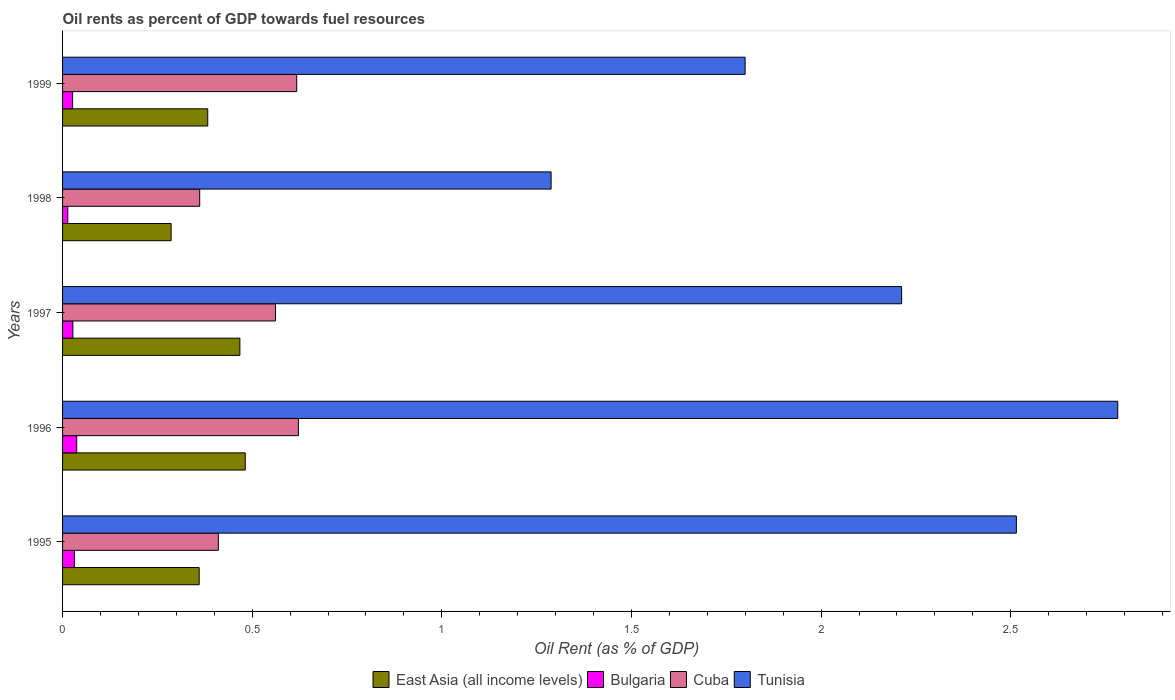How many different coloured bars are there?
Offer a very short reply. 4. Are the number of bars per tick equal to the number of legend labels?
Offer a terse response. Yes. How many bars are there on the 2nd tick from the top?
Provide a succinct answer. 4. What is the label of the 4th group of bars from the top?
Provide a short and direct response. 1996. What is the oil rent in Cuba in 1999?
Provide a short and direct response. 0.62. Across all years, what is the maximum oil rent in Bulgaria?
Keep it short and to the point. 0.04. Across all years, what is the minimum oil rent in Tunisia?
Your answer should be very brief. 1.29. In which year was the oil rent in Tunisia maximum?
Provide a short and direct response. 1996. What is the total oil rent in Tunisia in the graph?
Offer a very short reply. 10.6. What is the difference between the oil rent in Cuba in 1996 and that in 1997?
Provide a succinct answer. 0.06. What is the difference between the oil rent in Cuba in 1996 and the oil rent in Bulgaria in 1995?
Keep it short and to the point. 0.59. What is the average oil rent in East Asia (all income levels) per year?
Make the answer very short. 0.4. In the year 1996, what is the difference between the oil rent in Cuba and oil rent in East Asia (all income levels)?
Provide a succinct answer. 0.14. What is the ratio of the oil rent in Tunisia in 1997 to that in 1999?
Ensure brevity in your answer.  1.23. What is the difference between the highest and the second highest oil rent in Tunisia?
Keep it short and to the point. 0.27. What is the difference between the highest and the lowest oil rent in Bulgaria?
Your answer should be very brief. 0.02. Is the sum of the oil rent in East Asia (all income levels) in 1997 and 1999 greater than the maximum oil rent in Bulgaria across all years?
Your response must be concise. Yes. Is it the case that in every year, the sum of the oil rent in Tunisia and oil rent in Cuba is greater than the sum of oil rent in Bulgaria and oil rent in East Asia (all income levels)?
Make the answer very short. Yes. What does the 1st bar from the top in 1999 represents?
Make the answer very short. Tunisia. What does the 4th bar from the bottom in 1999 represents?
Provide a short and direct response. Tunisia. Are all the bars in the graph horizontal?
Your response must be concise. Yes. Are the values on the major ticks of X-axis written in scientific E-notation?
Your answer should be compact. No. Does the graph contain grids?
Offer a terse response. No. Where does the legend appear in the graph?
Your answer should be compact. Bottom center. What is the title of the graph?
Give a very brief answer. Oil rents as percent of GDP towards fuel resources. What is the label or title of the X-axis?
Your answer should be compact. Oil Rent (as % of GDP). What is the Oil Rent (as % of GDP) of East Asia (all income levels) in 1995?
Your answer should be very brief. 0.36. What is the Oil Rent (as % of GDP) in Bulgaria in 1995?
Provide a short and direct response. 0.03. What is the Oil Rent (as % of GDP) of Cuba in 1995?
Provide a succinct answer. 0.41. What is the Oil Rent (as % of GDP) in Tunisia in 1995?
Make the answer very short. 2.51. What is the Oil Rent (as % of GDP) in East Asia (all income levels) in 1996?
Offer a very short reply. 0.48. What is the Oil Rent (as % of GDP) of Bulgaria in 1996?
Give a very brief answer. 0.04. What is the Oil Rent (as % of GDP) in Cuba in 1996?
Make the answer very short. 0.62. What is the Oil Rent (as % of GDP) of Tunisia in 1996?
Provide a succinct answer. 2.78. What is the Oil Rent (as % of GDP) of East Asia (all income levels) in 1997?
Offer a terse response. 0.47. What is the Oil Rent (as % of GDP) of Bulgaria in 1997?
Your answer should be compact. 0.03. What is the Oil Rent (as % of GDP) in Cuba in 1997?
Make the answer very short. 0.56. What is the Oil Rent (as % of GDP) of Tunisia in 1997?
Your response must be concise. 2.21. What is the Oil Rent (as % of GDP) in East Asia (all income levels) in 1998?
Offer a very short reply. 0.29. What is the Oil Rent (as % of GDP) in Bulgaria in 1998?
Make the answer very short. 0.01. What is the Oil Rent (as % of GDP) of Cuba in 1998?
Give a very brief answer. 0.36. What is the Oil Rent (as % of GDP) in Tunisia in 1998?
Provide a succinct answer. 1.29. What is the Oil Rent (as % of GDP) of East Asia (all income levels) in 1999?
Your answer should be very brief. 0.38. What is the Oil Rent (as % of GDP) of Bulgaria in 1999?
Provide a succinct answer. 0.03. What is the Oil Rent (as % of GDP) of Cuba in 1999?
Give a very brief answer. 0.62. What is the Oil Rent (as % of GDP) of Tunisia in 1999?
Ensure brevity in your answer.  1.8. Across all years, what is the maximum Oil Rent (as % of GDP) in East Asia (all income levels)?
Your answer should be compact. 0.48. Across all years, what is the maximum Oil Rent (as % of GDP) in Bulgaria?
Keep it short and to the point. 0.04. Across all years, what is the maximum Oil Rent (as % of GDP) of Cuba?
Offer a very short reply. 0.62. Across all years, what is the maximum Oil Rent (as % of GDP) in Tunisia?
Make the answer very short. 2.78. Across all years, what is the minimum Oil Rent (as % of GDP) in East Asia (all income levels)?
Your answer should be very brief. 0.29. Across all years, what is the minimum Oil Rent (as % of GDP) in Bulgaria?
Offer a very short reply. 0.01. Across all years, what is the minimum Oil Rent (as % of GDP) in Cuba?
Keep it short and to the point. 0.36. Across all years, what is the minimum Oil Rent (as % of GDP) of Tunisia?
Provide a short and direct response. 1.29. What is the total Oil Rent (as % of GDP) of East Asia (all income levels) in the graph?
Your response must be concise. 1.98. What is the total Oil Rent (as % of GDP) in Bulgaria in the graph?
Your answer should be very brief. 0.14. What is the total Oil Rent (as % of GDP) in Cuba in the graph?
Keep it short and to the point. 2.57. What is the total Oil Rent (as % of GDP) in Tunisia in the graph?
Offer a very short reply. 10.6. What is the difference between the Oil Rent (as % of GDP) in East Asia (all income levels) in 1995 and that in 1996?
Your response must be concise. -0.12. What is the difference between the Oil Rent (as % of GDP) of Bulgaria in 1995 and that in 1996?
Give a very brief answer. -0.01. What is the difference between the Oil Rent (as % of GDP) of Cuba in 1995 and that in 1996?
Give a very brief answer. -0.21. What is the difference between the Oil Rent (as % of GDP) in Tunisia in 1995 and that in 1996?
Give a very brief answer. -0.27. What is the difference between the Oil Rent (as % of GDP) of East Asia (all income levels) in 1995 and that in 1997?
Your answer should be very brief. -0.11. What is the difference between the Oil Rent (as % of GDP) in Bulgaria in 1995 and that in 1997?
Give a very brief answer. 0. What is the difference between the Oil Rent (as % of GDP) in Cuba in 1995 and that in 1997?
Offer a very short reply. -0.15. What is the difference between the Oil Rent (as % of GDP) of Tunisia in 1995 and that in 1997?
Provide a succinct answer. 0.3. What is the difference between the Oil Rent (as % of GDP) of East Asia (all income levels) in 1995 and that in 1998?
Give a very brief answer. 0.07. What is the difference between the Oil Rent (as % of GDP) in Bulgaria in 1995 and that in 1998?
Make the answer very short. 0.02. What is the difference between the Oil Rent (as % of GDP) of Cuba in 1995 and that in 1998?
Provide a succinct answer. 0.05. What is the difference between the Oil Rent (as % of GDP) of Tunisia in 1995 and that in 1998?
Your answer should be compact. 1.23. What is the difference between the Oil Rent (as % of GDP) of East Asia (all income levels) in 1995 and that in 1999?
Offer a very short reply. -0.02. What is the difference between the Oil Rent (as % of GDP) in Bulgaria in 1995 and that in 1999?
Offer a terse response. 0. What is the difference between the Oil Rent (as % of GDP) in Cuba in 1995 and that in 1999?
Your response must be concise. -0.21. What is the difference between the Oil Rent (as % of GDP) in Tunisia in 1995 and that in 1999?
Ensure brevity in your answer.  0.72. What is the difference between the Oil Rent (as % of GDP) of East Asia (all income levels) in 1996 and that in 1997?
Provide a succinct answer. 0.01. What is the difference between the Oil Rent (as % of GDP) in Bulgaria in 1996 and that in 1997?
Provide a short and direct response. 0.01. What is the difference between the Oil Rent (as % of GDP) of Cuba in 1996 and that in 1997?
Keep it short and to the point. 0.06. What is the difference between the Oil Rent (as % of GDP) in Tunisia in 1996 and that in 1997?
Your answer should be very brief. 0.57. What is the difference between the Oil Rent (as % of GDP) of East Asia (all income levels) in 1996 and that in 1998?
Provide a short and direct response. 0.2. What is the difference between the Oil Rent (as % of GDP) of Bulgaria in 1996 and that in 1998?
Your response must be concise. 0.02. What is the difference between the Oil Rent (as % of GDP) of Cuba in 1996 and that in 1998?
Make the answer very short. 0.26. What is the difference between the Oil Rent (as % of GDP) of Tunisia in 1996 and that in 1998?
Offer a terse response. 1.49. What is the difference between the Oil Rent (as % of GDP) of East Asia (all income levels) in 1996 and that in 1999?
Your answer should be very brief. 0.1. What is the difference between the Oil Rent (as % of GDP) of Bulgaria in 1996 and that in 1999?
Keep it short and to the point. 0.01. What is the difference between the Oil Rent (as % of GDP) of Cuba in 1996 and that in 1999?
Your answer should be compact. 0. What is the difference between the Oil Rent (as % of GDP) in Tunisia in 1996 and that in 1999?
Ensure brevity in your answer.  0.98. What is the difference between the Oil Rent (as % of GDP) of East Asia (all income levels) in 1997 and that in 1998?
Your response must be concise. 0.18. What is the difference between the Oil Rent (as % of GDP) in Bulgaria in 1997 and that in 1998?
Offer a terse response. 0.01. What is the difference between the Oil Rent (as % of GDP) of Cuba in 1997 and that in 1998?
Give a very brief answer. 0.2. What is the difference between the Oil Rent (as % of GDP) of Tunisia in 1997 and that in 1998?
Your answer should be very brief. 0.92. What is the difference between the Oil Rent (as % of GDP) in East Asia (all income levels) in 1997 and that in 1999?
Offer a terse response. 0.08. What is the difference between the Oil Rent (as % of GDP) of Bulgaria in 1997 and that in 1999?
Your response must be concise. 0. What is the difference between the Oil Rent (as % of GDP) in Cuba in 1997 and that in 1999?
Your response must be concise. -0.06. What is the difference between the Oil Rent (as % of GDP) in Tunisia in 1997 and that in 1999?
Provide a short and direct response. 0.41. What is the difference between the Oil Rent (as % of GDP) in East Asia (all income levels) in 1998 and that in 1999?
Your response must be concise. -0.1. What is the difference between the Oil Rent (as % of GDP) in Bulgaria in 1998 and that in 1999?
Offer a terse response. -0.01. What is the difference between the Oil Rent (as % of GDP) in Cuba in 1998 and that in 1999?
Your response must be concise. -0.26. What is the difference between the Oil Rent (as % of GDP) of Tunisia in 1998 and that in 1999?
Your answer should be very brief. -0.51. What is the difference between the Oil Rent (as % of GDP) in East Asia (all income levels) in 1995 and the Oil Rent (as % of GDP) in Bulgaria in 1996?
Give a very brief answer. 0.32. What is the difference between the Oil Rent (as % of GDP) of East Asia (all income levels) in 1995 and the Oil Rent (as % of GDP) of Cuba in 1996?
Provide a succinct answer. -0.26. What is the difference between the Oil Rent (as % of GDP) in East Asia (all income levels) in 1995 and the Oil Rent (as % of GDP) in Tunisia in 1996?
Offer a very short reply. -2.42. What is the difference between the Oil Rent (as % of GDP) in Bulgaria in 1995 and the Oil Rent (as % of GDP) in Cuba in 1996?
Your answer should be compact. -0.59. What is the difference between the Oil Rent (as % of GDP) of Bulgaria in 1995 and the Oil Rent (as % of GDP) of Tunisia in 1996?
Make the answer very short. -2.75. What is the difference between the Oil Rent (as % of GDP) of Cuba in 1995 and the Oil Rent (as % of GDP) of Tunisia in 1996?
Offer a very short reply. -2.37. What is the difference between the Oil Rent (as % of GDP) in East Asia (all income levels) in 1995 and the Oil Rent (as % of GDP) in Bulgaria in 1997?
Offer a very short reply. 0.33. What is the difference between the Oil Rent (as % of GDP) of East Asia (all income levels) in 1995 and the Oil Rent (as % of GDP) of Cuba in 1997?
Provide a short and direct response. -0.2. What is the difference between the Oil Rent (as % of GDP) in East Asia (all income levels) in 1995 and the Oil Rent (as % of GDP) in Tunisia in 1997?
Your answer should be compact. -1.85. What is the difference between the Oil Rent (as % of GDP) in Bulgaria in 1995 and the Oil Rent (as % of GDP) in Cuba in 1997?
Ensure brevity in your answer.  -0.53. What is the difference between the Oil Rent (as % of GDP) in Bulgaria in 1995 and the Oil Rent (as % of GDP) in Tunisia in 1997?
Your response must be concise. -2.18. What is the difference between the Oil Rent (as % of GDP) in Cuba in 1995 and the Oil Rent (as % of GDP) in Tunisia in 1997?
Give a very brief answer. -1.8. What is the difference between the Oil Rent (as % of GDP) of East Asia (all income levels) in 1995 and the Oil Rent (as % of GDP) of Bulgaria in 1998?
Give a very brief answer. 0.35. What is the difference between the Oil Rent (as % of GDP) in East Asia (all income levels) in 1995 and the Oil Rent (as % of GDP) in Cuba in 1998?
Keep it short and to the point. -0. What is the difference between the Oil Rent (as % of GDP) of East Asia (all income levels) in 1995 and the Oil Rent (as % of GDP) of Tunisia in 1998?
Your answer should be very brief. -0.93. What is the difference between the Oil Rent (as % of GDP) of Bulgaria in 1995 and the Oil Rent (as % of GDP) of Cuba in 1998?
Your response must be concise. -0.33. What is the difference between the Oil Rent (as % of GDP) in Bulgaria in 1995 and the Oil Rent (as % of GDP) in Tunisia in 1998?
Make the answer very short. -1.26. What is the difference between the Oil Rent (as % of GDP) in Cuba in 1995 and the Oil Rent (as % of GDP) in Tunisia in 1998?
Provide a short and direct response. -0.88. What is the difference between the Oil Rent (as % of GDP) in East Asia (all income levels) in 1995 and the Oil Rent (as % of GDP) in Bulgaria in 1999?
Ensure brevity in your answer.  0.33. What is the difference between the Oil Rent (as % of GDP) in East Asia (all income levels) in 1995 and the Oil Rent (as % of GDP) in Cuba in 1999?
Ensure brevity in your answer.  -0.26. What is the difference between the Oil Rent (as % of GDP) of East Asia (all income levels) in 1995 and the Oil Rent (as % of GDP) of Tunisia in 1999?
Provide a short and direct response. -1.44. What is the difference between the Oil Rent (as % of GDP) of Bulgaria in 1995 and the Oil Rent (as % of GDP) of Cuba in 1999?
Your response must be concise. -0.59. What is the difference between the Oil Rent (as % of GDP) in Bulgaria in 1995 and the Oil Rent (as % of GDP) in Tunisia in 1999?
Offer a terse response. -1.77. What is the difference between the Oil Rent (as % of GDP) in Cuba in 1995 and the Oil Rent (as % of GDP) in Tunisia in 1999?
Provide a succinct answer. -1.39. What is the difference between the Oil Rent (as % of GDP) of East Asia (all income levels) in 1996 and the Oil Rent (as % of GDP) of Bulgaria in 1997?
Offer a terse response. 0.45. What is the difference between the Oil Rent (as % of GDP) of East Asia (all income levels) in 1996 and the Oil Rent (as % of GDP) of Cuba in 1997?
Give a very brief answer. -0.08. What is the difference between the Oil Rent (as % of GDP) in East Asia (all income levels) in 1996 and the Oil Rent (as % of GDP) in Tunisia in 1997?
Give a very brief answer. -1.73. What is the difference between the Oil Rent (as % of GDP) in Bulgaria in 1996 and the Oil Rent (as % of GDP) in Cuba in 1997?
Offer a terse response. -0.52. What is the difference between the Oil Rent (as % of GDP) of Bulgaria in 1996 and the Oil Rent (as % of GDP) of Tunisia in 1997?
Ensure brevity in your answer.  -2.18. What is the difference between the Oil Rent (as % of GDP) of Cuba in 1996 and the Oil Rent (as % of GDP) of Tunisia in 1997?
Your response must be concise. -1.59. What is the difference between the Oil Rent (as % of GDP) in East Asia (all income levels) in 1996 and the Oil Rent (as % of GDP) in Bulgaria in 1998?
Provide a succinct answer. 0.47. What is the difference between the Oil Rent (as % of GDP) in East Asia (all income levels) in 1996 and the Oil Rent (as % of GDP) in Cuba in 1998?
Offer a terse response. 0.12. What is the difference between the Oil Rent (as % of GDP) in East Asia (all income levels) in 1996 and the Oil Rent (as % of GDP) in Tunisia in 1998?
Make the answer very short. -0.81. What is the difference between the Oil Rent (as % of GDP) in Bulgaria in 1996 and the Oil Rent (as % of GDP) in Cuba in 1998?
Your response must be concise. -0.32. What is the difference between the Oil Rent (as % of GDP) of Bulgaria in 1996 and the Oil Rent (as % of GDP) of Tunisia in 1998?
Give a very brief answer. -1.25. What is the difference between the Oil Rent (as % of GDP) in Cuba in 1996 and the Oil Rent (as % of GDP) in Tunisia in 1998?
Provide a succinct answer. -0.67. What is the difference between the Oil Rent (as % of GDP) in East Asia (all income levels) in 1996 and the Oil Rent (as % of GDP) in Bulgaria in 1999?
Give a very brief answer. 0.46. What is the difference between the Oil Rent (as % of GDP) in East Asia (all income levels) in 1996 and the Oil Rent (as % of GDP) in Cuba in 1999?
Keep it short and to the point. -0.14. What is the difference between the Oil Rent (as % of GDP) in East Asia (all income levels) in 1996 and the Oil Rent (as % of GDP) in Tunisia in 1999?
Your answer should be compact. -1.32. What is the difference between the Oil Rent (as % of GDP) in Bulgaria in 1996 and the Oil Rent (as % of GDP) in Cuba in 1999?
Offer a very short reply. -0.58. What is the difference between the Oil Rent (as % of GDP) of Bulgaria in 1996 and the Oil Rent (as % of GDP) of Tunisia in 1999?
Offer a terse response. -1.76. What is the difference between the Oil Rent (as % of GDP) in Cuba in 1996 and the Oil Rent (as % of GDP) in Tunisia in 1999?
Your answer should be compact. -1.18. What is the difference between the Oil Rent (as % of GDP) in East Asia (all income levels) in 1997 and the Oil Rent (as % of GDP) in Bulgaria in 1998?
Ensure brevity in your answer.  0.45. What is the difference between the Oil Rent (as % of GDP) of East Asia (all income levels) in 1997 and the Oil Rent (as % of GDP) of Cuba in 1998?
Make the answer very short. 0.11. What is the difference between the Oil Rent (as % of GDP) in East Asia (all income levels) in 1997 and the Oil Rent (as % of GDP) in Tunisia in 1998?
Give a very brief answer. -0.82. What is the difference between the Oil Rent (as % of GDP) of Bulgaria in 1997 and the Oil Rent (as % of GDP) of Cuba in 1998?
Your answer should be compact. -0.33. What is the difference between the Oil Rent (as % of GDP) in Bulgaria in 1997 and the Oil Rent (as % of GDP) in Tunisia in 1998?
Give a very brief answer. -1.26. What is the difference between the Oil Rent (as % of GDP) in Cuba in 1997 and the Oil Rent (as % of GDP) in Tunisia in 1998?
Keep it short and to the point. -0.73. What is the difference between the Oil Rent (as % of GDP) of East Asia (all income levels) in 1997 and the Oil Rent (as % of GDP) of Bulgaria in 1999?
Provide a succinct answer. 0.44. What is the difference between the Oil Rent (as % of GDP) in East Asia (all income levels) in 1997 and the Oil Rent (as % of GDP) in Cuba in 1999?
Give a very brief answer. -0.15. What is the difference between the Oil Rent (as % of GDP) in East Asia (all income levels) in 1997 and the Oil Rent (as % of GDP) in Tunisia in 1999?
Offer a very short reply. -1.33. What is the difference between the Oil Rent (as % of GDP) in Bulgaria in 1997 and the Oil Rent (as % of GDP) in Cuba in 1999?
Ensure brevity in your answer.  -0.59. What is the difference between the Oil Rent (as % of GDP) of Bulgaria in 1997 and the Oil Rent (as % of GDP) of Tunisia in 1999?
Your answer should be very brief. -1.77. What is the difference between the Oil Rent (as % of GDP) of Cuba in 1997 and the Oil Rent (as % of GDP) of Tunisia in 1999?
Ensure brevity in your answer.  -1.24. What is the difference between the Oil Rent (as % of GDP) in East Asia (all income levels) in 1998 and the Oil Rent (as % of GDP) in Bulgaria in 1999?
Your answer should be compact. 0.26. What is the difference between the Oil Rent (as % of GDP) in East Asia (all income levels) in 1998 and the Oil Rent (as % of GDP) in Cuba in 1999?
Your response must be concise. -0.33. What is the difference between the Oil Rent (as % of GDP) in East Asia (all income levels) in 1998 and the Oil Rent (as % of GDP) in Tunisia in 1999?
Keep it short and to the point. -1.51. What is the difference between the Oil Rent (as % of GDP) in Bulgaria in 1998 and the Oil Rent (as % of GDP) in Cuba in 1999?
Ensure brevity in your answer.  -0.6. What is the difference between the Oil Rent (as % of GDP) in Bulgaria in 1998 and the Oil Rent (as % of GDP) in Tunisia in 1999?
Ensure brevity in your answer.  -1.79. What is the difference between the Oil Rent (as % of GDP) of Cuba in 1998 and the Oil Rent (as % of GDP) of Tunisia in 1999?
Make the answer very short. -1.44. What is the average Oil Rent (as % of GDP) of East Asia (all income levels) per year?
Ensure brevity in your answer.  0.4. What is the average Oil Rent (as % of GDP) of Bulgaria per year?
Your answer should be very brief. 0.03. What is the average Oil Rent (as % of GDP) in Cuba per year?
Offer a terse response. 0.51. What is the average Oil Rent (as % of GDP) in Tunisia per year?
Offer a terse response. 2.12. In the year 1995, what is the difference between the Oil Rent (as % of GDP) in East Asia (all income levels) and Oil Rent (as % of GDP) in Bulgaria?
Give a very brief answer. 0.33. In the year 1995, what is the difference between the Oil Rent (as % of GDP) in East Asia (all income levels) and Oil Rent (as % of GDP) in Cuba?
Offer a very short reply. -0.05. In the year 1995, what is the difference between the Oil Rent (as % of GDP) of East Asia (all income levels) and Oil Rent (as % of GDP) of Tunisia?
Keep it short and to the point. -2.15. In the year 1995, what is the difference between the Oil Rent (as % of GDP) of Bulgaria and Oil Rent (as % of GDP) of Cuba?
Ensure brevity in your answer.  -0.38. In the year 1995, what is the difference between the Oil Rent (as % of GDP) of Bulgaria and Oil Rent (as % of GDP) of Tunisia?
Make the answer very short. -2.48. In the year 1995, what is the difference between the Oil Rent (as % of GDP) in Cuba and Oil Rent (as % of GDP) in Tunisia?
Offer a terse response. -2.1. In the year 1996, what is the difference between the Oil Rent (as % of GDP) of East Asia (all income levels) and Oil Rent (as % of GDP) of Bulgaria?
Ensure brevity in your answer.  0.44. In the year 1996, what is the difference between the Oil Rent (as % of GDP) of East Asia (all income levels) and Oil Rent (as % of GDP) of Cuba?
Your answer should be compact. -0.14. In the year 1996, what is the difference between the Oil Rent (as % of GDP) in East Asia (all income levels) and Oil Rent (as % of GDP) in Tunisia?
Offer a very short reply. -2.3. In the year 1996, what is the difference between the Oil Rent (as % of GDP) of Bulgaria and Oil Rent (as % of GDP) of Cuba?
Give a very brief answer. -0.58. In the year 1996, what is the difference between the Oil Rent (as % of GDP) in Bulgaria and Oil Rent (as % of GDP) in Tunisia?
Provide a succinct answer. -2.74. In the year 1996, what is the difference between the Oil Rent (as % of GDP) of Cuba and Oil Rent (as % of GDP) of Tunisia?
Your answer should be compact. -2.16. In the year 1997, what is the difference between the Oil Rent (as % of GDP) in East Asia (all income levels) and Oil Rent (as % of GDP) in Bulgaria?
Your answer should be compact. 0.44. In the year 1997, what is the difference between the Oil Rent (as % of GDP) of East Asia (all income levels) and Oil Rent (as % of GDP) of Cuba?
Your answer should be compact. -0.09. In the year 1997, what is the difference between the Oil Rent (as % of GDP) of East Asia (all income levels) and Oil Rent (as % of GDP) of Tunisia?
Offer a very short reply. -1.74. In the year 1997, what is the difference between the Oil Rent (as % of GDP) of Bulgaria and Oil Rent (as % of GDP) of Cuba?
Offer a terse response. -0.53. In the year 1997, what is the difference between the Oil Rent (as % of GDP) in Bulgaria and Oil Rent (as % of GDP) in Tunisia?
Ensure brevity in your answer.  -2.19. In the year 1997, what is the difference between the Oil Rent (as % of GDP) of Cuba and Oil Rent (as % of GDP) of Tunisia?
Ensure brevity in your answer.  -1.65. In the year 1998, what is the difference between the Oil Rent (as % of GDP) in East Asia (all income levels) and Oil Rent (as % of GDP) in Bulgaria?
Provide a short and direct response. 0.27. In the year 1998, what is the difference between the Oil Rent (as % of GDP) in East Asia (all income levels) and Oil Rent (as % of GDP) in Cuba?
Provide a succinct answer. -0.08. In the year 1998, what is the difference between the Oil Rent (as % of GDP) of East Asia (all income levels) and Oil Rent (as % of GDP) of Tunisia?
Give a very brief answer. -1. In the year 1998, what is the difference between the Oil Rent (as % of GDP) in Bulgaria and Oil Rent (as % of GDP) in Cuba?
Provide a succinct answer. -0.35. In the year 1998, what is the difference between the Oil Rent (as % of GDP) in Bulgaria and Oil Rent (as % of GDP) in Tunisia?
Offer a terse response. -1.27. In the year 1998, what is the difference between the Oil Rent (as % of GDP) of Cuba and Oil Rent (as % of GDP) of Tunisia?
Your response must be concise. -0.93. In the year 1999, what is the difference between the Oil Rent (as % of GDP) of East Asia (all income levels) and Oil Rent (as % of GDP) of Bulgaria?
Give a very brief answer. 0.36. In the year 1999, what is the difference between the Oil Rent (as % of GDP) of East Asia (all income levels) and Oil Rent (as % of GDP) of Cuba?
Your response must be concise. -0.23. In the year 1999, what is the difference between the Oil Rent (as % of GDP) of East Asia (all income levels) and Oil Rent (as % of GDP) of Tunisia?
Your answer should be very brief. -1.42. In the year 1999, what is the difference between the Oil Rent (as % of GDP) in Bulgaria and Oil Rent (as % of GDP) in Cuba?
Provide a short and direct response. -0.59. In the year 1999, what is the difference between the Oil Rent (as % of GDP) of Bulgaria and Oil Rent (as % of GDP) of Tunisia?
Your answer should be very brief. -1.77. In the year 1999, what is the difference between the Oil Rent (as % of GDP) in Cuba and Oil Rent (as % of GDP) in Tunisia?
Give a very brief answer. -1.18. What is the ratio of the Oil Rent (as % of GDP) in East Asia (all income levels) in 1995 to that in 1996?
Ensure brevity in your answer.  0.75. What is the ratio of the Oil Rent (as % of GDP) of Bulgaria in 1995 to that in 1996?
Keep it short and to the point. 0.84. What is the ratio of the Oil Rent (as % of GDP) in Cuba in 1995 to that in 1996?
Your answer should be very brief. 0.66. What is the ratio of the Oil Rent (as % of GDP) in Tunisia in 1995 to that in 1996?
Provide a short and direct response. 0.9. What is the ratio of the Oil Rent (as % of GDP) in East Asia (all income levels) in 1995 to that in 1997?
Give a very brief answer. 0.77. What is the ratio of the Oil Rent (as % of GDP) of Bulgaria in 1995 to that in 1997?
Provide a short and direct response. 1.14. What is the ratio of the Oil Rent (as % of GDP) of Cuba in 1995 to that in 1997?
Keep it short and to the point. 0.73. What is the ratio of the Oil Rent (as % of GDP) of Tunisia in 1995 to that in 1997?
Make the answer very short. 1.14. What is the ratio of the Oil Rent (as % of GDP) of East Asia (all income levels) in 1995 to that in 1998?
Keep it short and to the point. 1.26. What is the ratio of the Oil Rent (as % of GDP) of Bulgaria in 1995 to that in 1998?
Your answer should be compact. 2.27. What is the ratio of the Oil Rent (as % of GDP) of Cuba in 1995 to that in 1998?
Ensure brevity in your answer.  1.14. What is the ratio of the Oil Rent (as % of GDP) in Tunisia in 1995 to that in 1998?
Provide a succinct answer. 1.95. What is the ratio of the Oil Rent (as % of GDP) in East Asia (all income levels) in 1995 to that in 1999?
Offer a very short reply. 0.94. What is the ratio of the Oil Rent (as % of GDP) in Bulgaria in 1995 to that in 1999?
Give a very brief answer. 1.17. What is the ratio of the Oil Rent (as % of GDP) in Cuba in 1995 to that in 1999?
Keep it short and to the point. 0.67. What is the ratio of the Oil Rent (as % of GDP) of Tunisia in 1995 to that in 1999?
Your answer should be compact. 1.4. What is the ratio of the Oil Rent (as % of GDP) in East Asia (all income levels) in 1996 to that in 1997?
Give a very brief answer. 1.03. What is the ratio of the Oil Rent (as % of GDP) in Bulgaria in 1996 to that in 1997?
Keep it short and to the point. 1.37. What is the ratio of the Oil Rent (as % of GDP) of Cuba in 1996 to that in 1997?
Your response must be concise. 1.11. What is the ratio of the Oil Rent (as % of GDP) of Tunisia in 1996 to that in 1997?
Provide a succinct answer. 1.26. What is the ratio of the Oil Rent (as % of GDP) of East Asia (all income levels) in 1996 to that in 1998?
Keep it short and to the point. 1.68. What is the ratio of the Oil Rent (as % of GDP) in Bulgaria in 1996 to that in 1998?
Your answer should be compact. 2.71. What is the ratio of the Oil Rent (as % of GDP) in Cuba in 1996 to that in 1998?
Provide a short and direct response. 1.72. What is the ratio of the Oil Rent (as % of GDP) in Tunisia in 1996 to that in 1998?
Ensure brevity in your answer.  2.16. What is the ratio of the Oil Rent (as % of GDP) in East Asia (all income levels) in 1996 to that in 1999?
Give a very brief answer. 1.26. What is the ratio of the Oil Rent (as % of GDP) in Bulgaria in 1996 to that in 1999?
Your answer should be very brief. 1.4. What is the ratio of the Oil Rent (as % of GDP) of Cuba in 1996 to that in 1999?
Your answer should be very brief. 1.01. What is the ratio of the Oil Rent (as % of GDP) in Tunisia in 1996 to that in 1999?
Your answer should be compact. 1.55. What is the ratio of the Oil Rent (as % of GDP) of East Asia (all income levels) in 1997 to that in 1998?
Provide a succinct answer. 1.63. What is the ratio of the Oil Rent (as % of GDP) of Bulgaria in 1997 to that in 1998?
Your answer should be compact. 1.98. What is the ratio of the Oil Rent (as % of GDP) of Cuba in 1997 to that in 1998?
Your answer should be very brief. 1.55. What is the ratio of the Oil Rent (as % of GDP) of Tunisia in 1997 to that in 1998?
Your response must be concise. 1.72. What is the ratio of the Oil Rent (as % of GDP) of East Asia (all income levels) in 1997 to that in 1999?
Your answer should be compact. 1.22. What is the ratio of the Oil Rent (as % of GDP) of Bulgaria in 1997 to that in 1999?
Keep it short and to the point. 1.02. What is the ratio of the Oil Rent (as % of GDP) in Cuba in 1997 to that in 1999?
Make the answer very short. 0.91. What is the ratio of the Oil Rent (as % of GDP) of Tunisia in 1997 to that in 1999?
Your answer should be compact. 1.23. What is the ratio of the Oil Rent (as % of GDP) of East Asia (all income levels) in 1998 to that in 1999?
Ensure brevity in your answer.  0.75. What is the ratio of the Oil Rent (as % of GDP) of Bulgaria in 1998 to that in 1999?
Make the answer very short. 0.52. What is the ratio of the Oil Rent (as % of GDP) of Cuba in 1998 to that in 1999?
Give a very brief answer. 0.59. What is the ratio of the Oil Rent (as % of GDP) in Tunisia in 1998 to that in 1999?
Ensure brevity in your answer.  0.72. What is the difference between the highest and the second highest Oil Rent (as % of GDP) in East Asia (all income levels)?
Keep it short and to the point. 0.01. What is the difference between the highest and the second highest Oil Rent (as % of GDP) of Bulgaria?
Give a very brief answer. 0.01. What is the difference between the highest and the second highest Oil Rent (as % of GDP) in Cuba?
Ensure brevity in your answer.  0. What is the difference between the highest and the second highest Oil Rent (as % of GDP) of Tunisia?
Keep it short and to the point. 0.27. What is the difference between the highest and the lowest Oil Rent (as % of GDP) of East Asia (all income levels)?
Ensure brevity in your answer.  0.2. What is the difference between the highest and the lowest Oil Rent (as % of GDP) of Bulgaria?
Keep it short and to the point. 0.02. What is the difference between the highest and the lowest Oil Rent (as % of GDP) of Cuba?
Give a very brief answer. 0.26. What is the difference between the highest and the lowest Oil Rent (as % of GDP) of Tunisia?
Give a very brief answer. 1.49. 